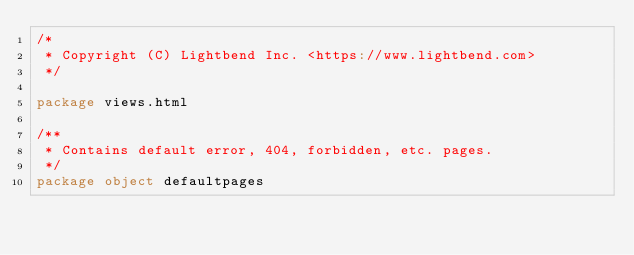<code> <loc_0><loc_0><loc_500><loc_500><_Scala_>/*
 * Copyright (C) Lightbend Inc. <https://www.lightbend.com>
 */

package views.html

/**
 * Contains default error, 404, forbidden, etc. pages.
 */
package object defaultpages
</code> 